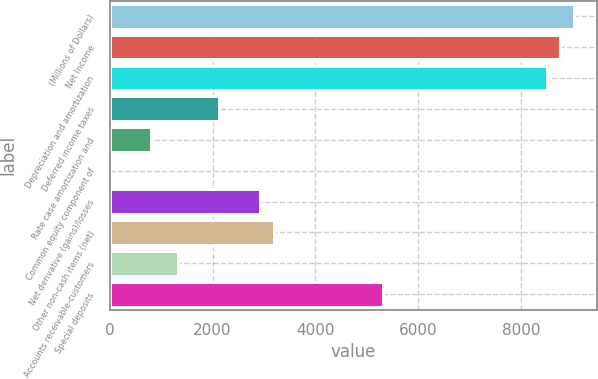Convert chart to OTSL. <chart><loc_0><loc_0><loc_500><loc_500><bar_chart><fcel>(Millions of Dollars)<fcel>Net Income<fcel>Depreciation and amortization<fcel>Deferred income taxes<fcel>Rate case amortization and<fcel>Common equity component of<fcel>Net derivative (gains)/losses<fcel>Other non-cash items (net)<fcel>Accounts receivable-customers<fcel>Special deposits<nl><fcel>9031<fcel>8765.5<fcel>8500<fcel>2128<fcel>800.5<fcel>4<fcel>2924.5<fcel>3190<fcel>1331.5<fcel>5314<nl></chart> 